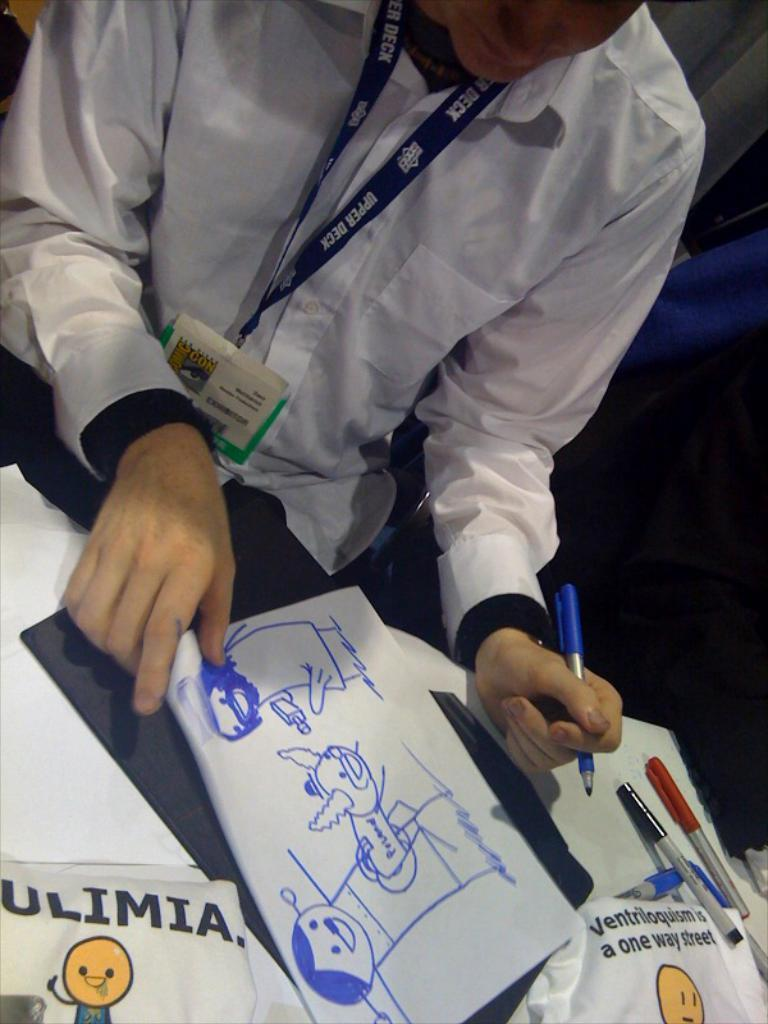What is the man in the image holding? The man is holding a pen. What is in front of the man? There is a table in front of the man. What can be seen on the table? There is a paper with an art, pens, and other objects on the table. What might the man be doing with the pen? The man might be drawing or writing on the paper with the pen. What type of cactus is on the table in the image? There is no cactus present in the image; the table contains a paper with an art, pens, and other objects. 